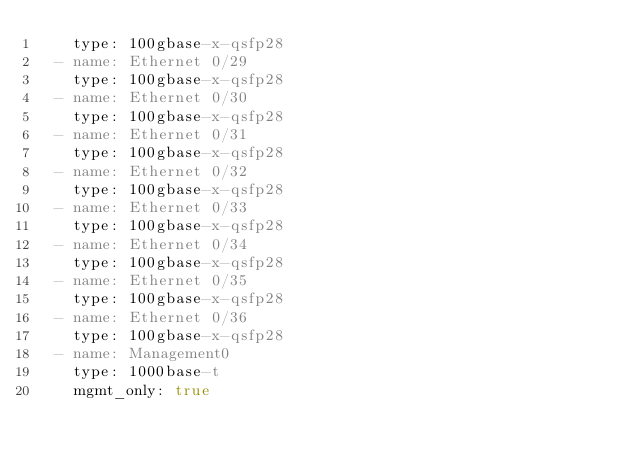<code> <loc_0><loc_0><loc_500><loc_500><_YAML_>    type: 100gbase-x-qsfp28
  - name: Ethernet 0/29
    type: 100gbase-x-qsfp28
  - name: Ethernet 0/30
    type: 100gbase-x-qsfp28
  - name: Ethernet 0/31
    type: 100gbase-x-qsfp28
  - name: Ethernet 0/32
    type: 100gbase-x-qsfp28
  - name: Ethernet 0/33
    type: 100gbase-x-qsfp28
  - name: Ethernet 0/34
    type: 100gbase-x-qsfp28
  - name: Ethernet 0/35
    type: 100gbase-x-qsfp28
  - name: Ethernet 0/36
    type: 100gbase-x-qsfp28
  - name: Management0
    type: 1000base-t
    mgmt_only: true
</code> 